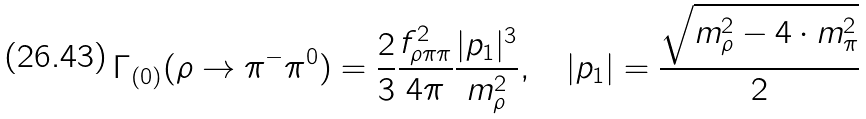<formula> <loc_0><loc_0><loc_500><loc_500>\Gamma _ { ( 0 ) } ( \rho \to \pi ^ { - } \pi ^ { 0 } ) = \frac { 2 } { 3 } \frac { f _ { \rho \pi \pi } ^ { 2 } } { 4 \pi } \frac { | p _ { 1 } | ^ { 3 } } { m _ { \rho } ^ { 2 } } , \quad | p _ { 1 } | = \frac { \sqrt { m _ { \rho } ^ { 2 } - 4 \cdot m _ { \pi } ^ { 2 } } } { 2 }</formula> 